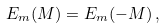<formula> <loc_0><loc_0><loc_500><loc_500>E _ { m } ( M ) = E _ { m } ( - M ) \, ,</formula> 